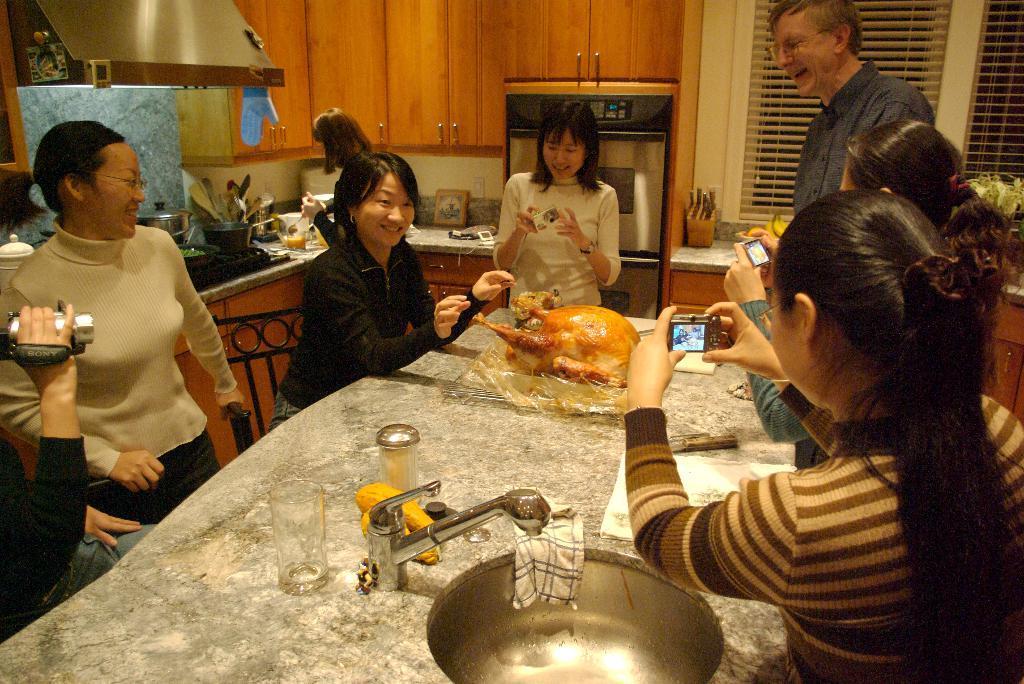How would you summarize this image in a sentence or two? In this image there is a table and we can see a meat, glass, sink, cloth and a jar placed on the table. We can see people sitting. On the left we can see a person's hand holding a camera. In the background there is a counter top and we can see things placed on the counter top and there is an oven and cupboards. On the right we can see windows and there are blinds. 